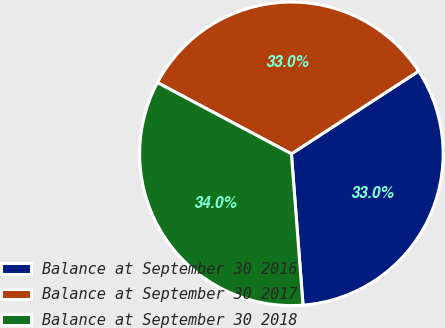Convert chart. <chart><loc_0><loc_0><loc_500><loc_500><pie_chart><fcel>Balance at September 30 2016<fcel>Balance at September 30 2017<fcel>Balance at September 30 2018<nl><fcel>32.95%<fcel>33.05%<fcel>34.0%<nl></chart> 